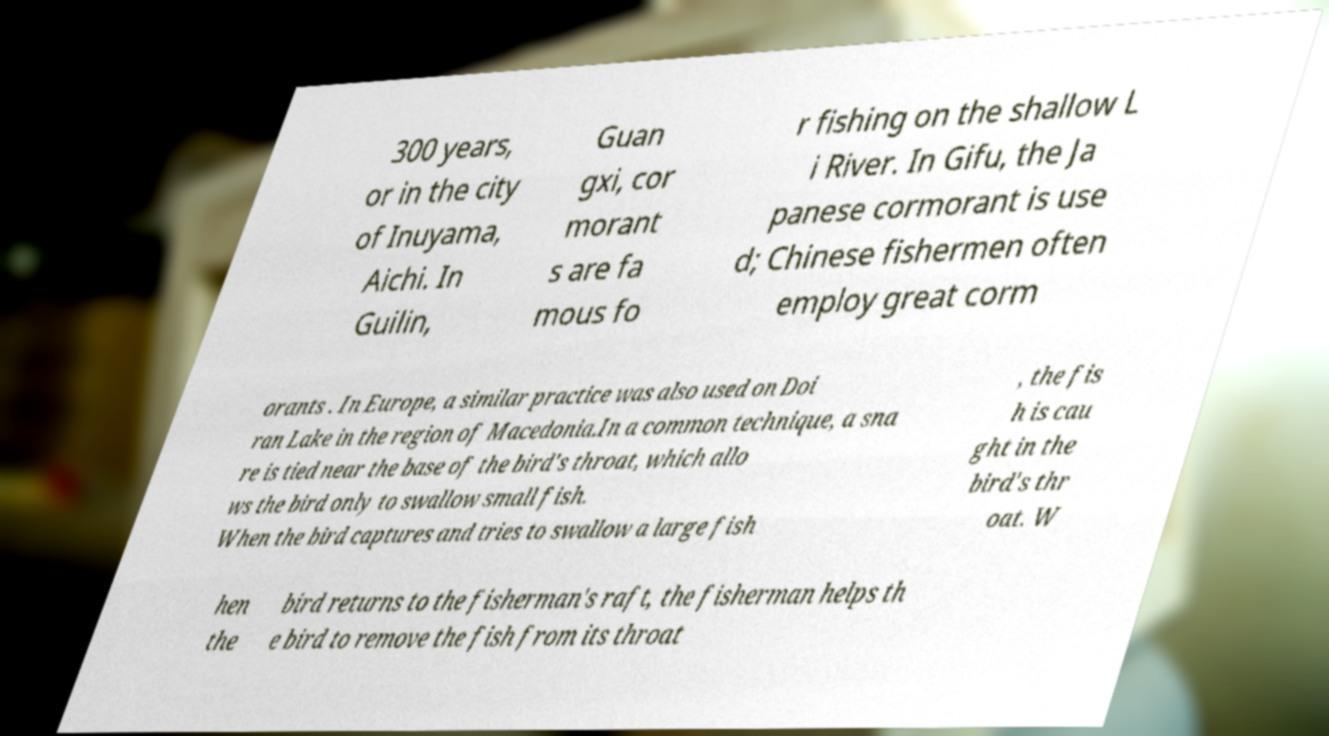Could you assist in decoding the text presented in this image and type it out clearly? 300 years, or in the city of Inuyama, Aichi. In Guilin, Guan gxi, cor morant s are fa mous fo r fishing on the shallow L i River. In Gifu, the Ja panese cormorant is use d; Chinese fishermen often employ great corm orants . In Europe, a similar practice was also used on Doi ran Lake in the region of Macedonia.In a common technique, a sna re is tied near the base of the bird's throat, which allo ws the bird only to swallow small fish. When the bird captures and tries to swallow a large fish , the fis h is cau ght in the bird's thr oat. W hen the bird returns to the fisherman's raft, the fisherman helps th e bird to remove the fish from its throat 